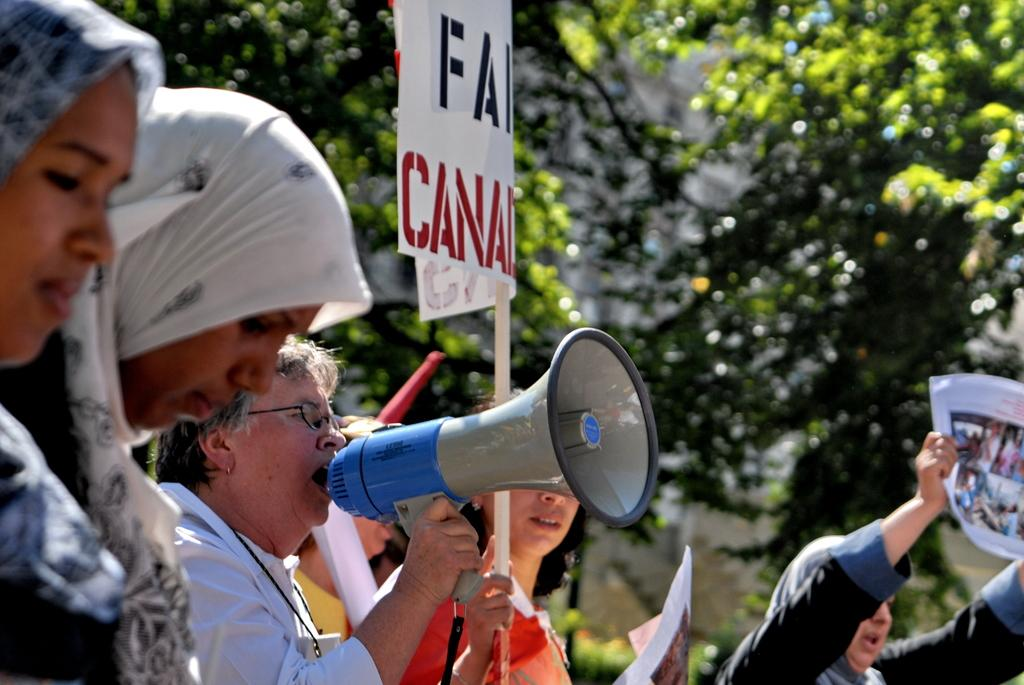How many people are present in the image? There are many people in the image. What are the people holding in the image? The people are holding placards. Can you describe the woman in the image? The woman is in the image, and she is talking into a microphone. What can be seen in the background of the image? There are trees in the background of the image. What type of fowl can be seen perched on the woman's shoulder in the image? There is no fowl present on the woman's shoulder in the image. What root is visible in the image? There is no root visible in the image. 